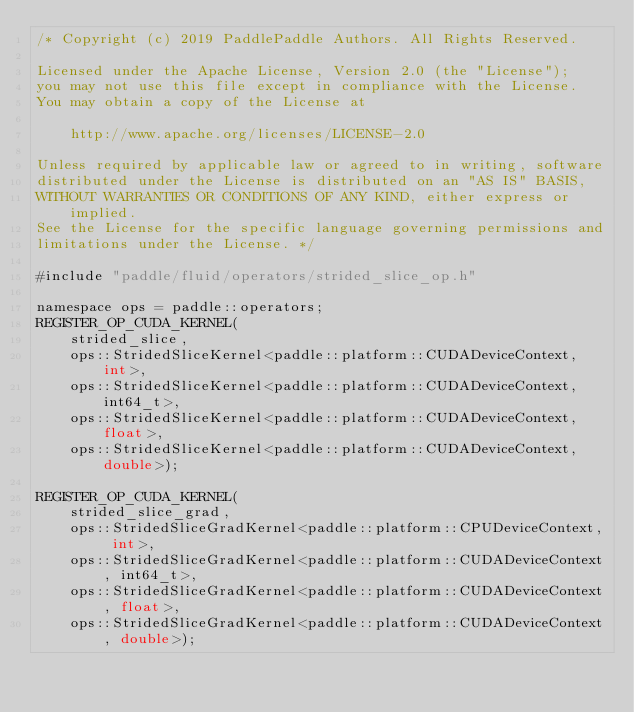Convert code to text. <code><loc_0><loc_0><loc_500><loc_500><_Cuda_>/* Copyright (c) 2019 PaddlePaddle Authors. All Rights Reserved.

Licensed under the Apache License, Version 2.0 (the "License");
you may not use this file except in compliance with the License.
You may obtain a copy of the License at

    http://www.apache.org/licenses/LICENSE-2.0

Unless required by applicable law or agreed to in writing, software
distributed under the License is distributed on an "AS IS" BASIS,
WITHOUT WARRANTIES OR CONDITIONS OF ANY KIND, either express or implied.
See the License for the specific language governing permissions and
limitations under the License. */

#include "paddle/fluid/operators/strided_slice_op.h"

namespace ops = paddle::operators;
REGISTER_OP_CUDA_KERNEL(
    strided_slice,
    ops::StridedSliceKernel<paddle::platform::CUDADeviceContext, int>,
    ops::StridedSliceKernel<paddle::platform::CUDADeviceContext, int64_t>,
    ops::StridedSliceKernel<paddle::platform::CUDADeviceContext, float>,
    ops::StridedSliceKernel<paddle::platform::CUDADeviceContext, double>);

REGISTER_OP_CUDA_KERNEL(
    strided_slice_grad,
    ops::StridedSliceGradKernel<paddle::platform::CPUDeviceContext, int>,
    ops::StridedSliceGradKernel<paddle::platform::CUDADeviceContext, int64_t>,
    ops::StridedSliceGradKernel<paddle::platform::CUDADeviceContext, float>,
    ops::StridedSliceGradKernel<paddle::platform::CUDADeviceContext, double>);
</code> 